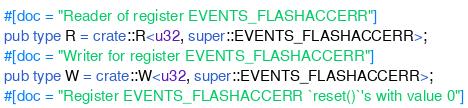Convert code to text. <code><loc_0><loc_0><loc_500><loc_500><_Rust_>#[doc = "Reader of register EVENTS_FLASHACCERR"]
pub type R = crate::R<u32, super::EVENTS_FLASHACCERR>;
#[doc = "Writer for register EVENTS_FLASHACCERR"]
pub type W = crate::W<u32, super::EVENTS_FLASHACCERR>;
#[doc = "Register EVENTS_FLASHACCERR `reset()`'s with value 0"]</code> 